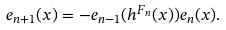<formula> <loc_0><loc_0><loc_500><loc_500>e _ { n + 1 } ( x ) = - e _ { n - 1 } ( h ^ { F _ { n } } ( x ) ) e _ { n } ( x ) .</formula> 